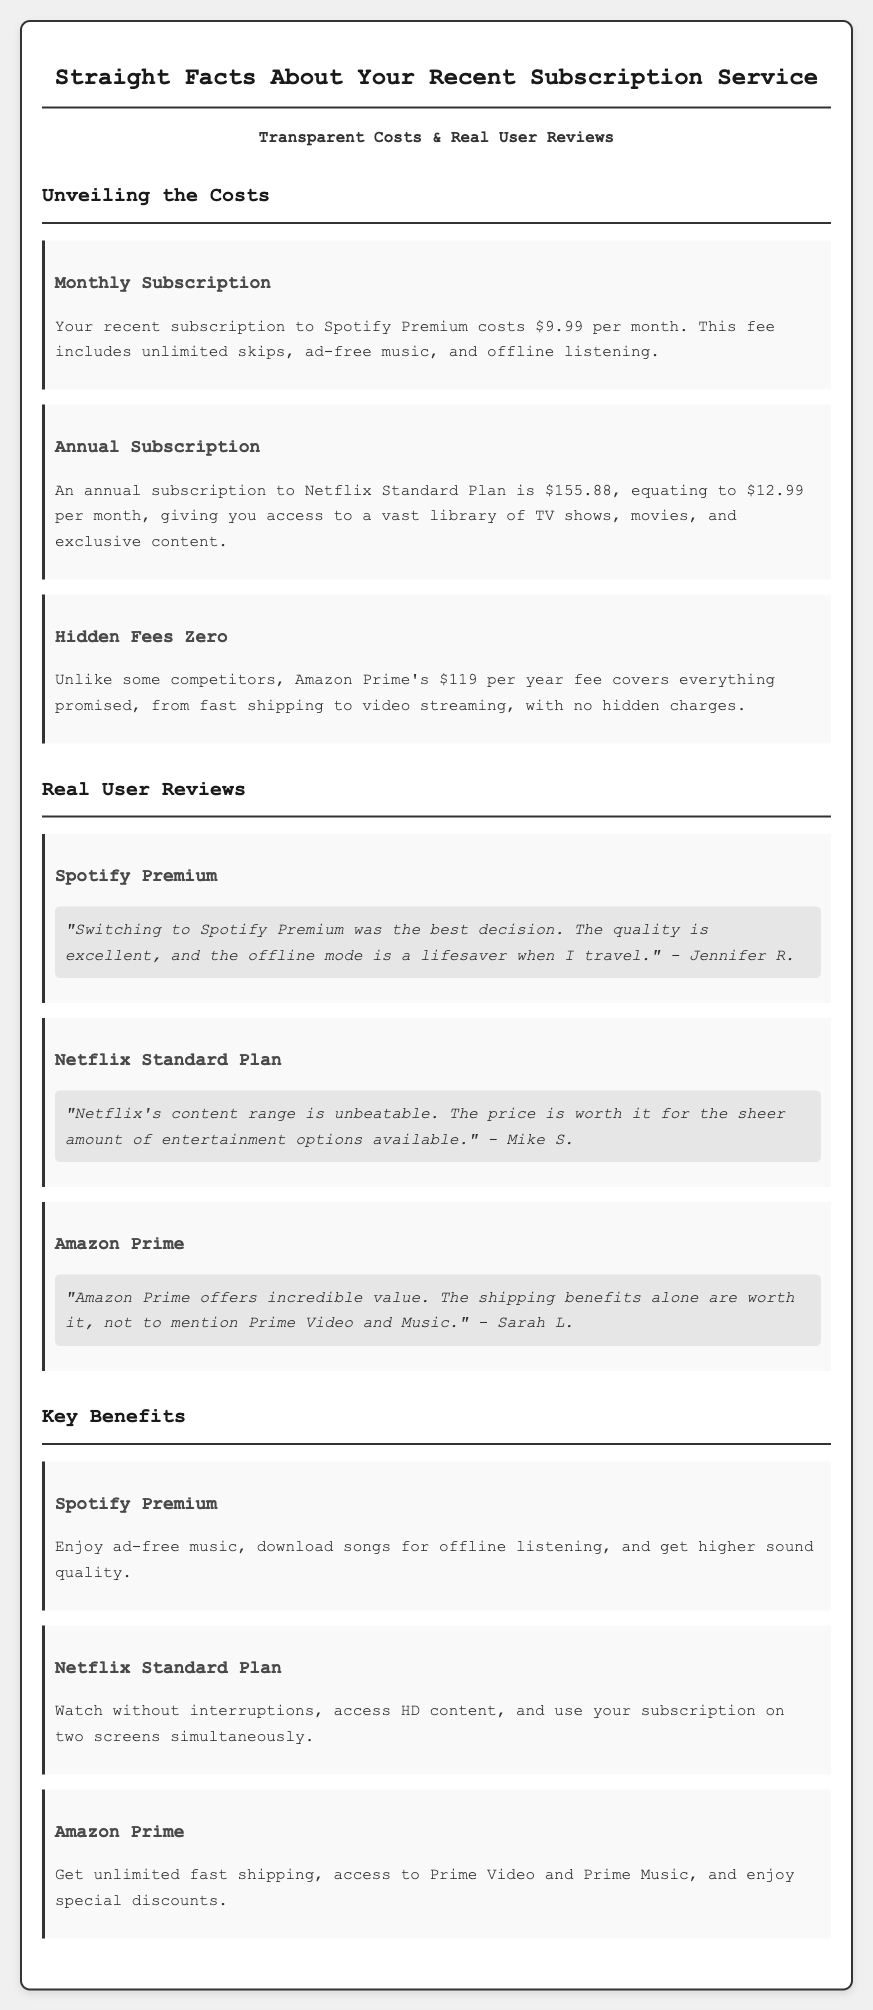What is the cost of Spotify Premium? The document states that the monthly subscription to Spotify Premium costs $9.99.
Answer: $9.99 How much is the annual subscription for Netflix Standard Plan? According to the document, the annual subscription to the Netflix Standard Plan is $155.88.
Answer: $155.88 What is stated about hidden fees for Amazon Prime? The document claims that Amazon Prime's fee covers everything promised with no hidden charges.
Answer: No hidden charges Who left a review for Spotify Premium? The document includes a review from Jennifer R. regarding Spotify Premium.
Answer: Jennifer R What key benefit of Netflix Standard Plan is mentioned? The document mentions that you can watch without interruptions as a benefit of Netflix Standard Plan.
Answer: Watch without interruptions What do users get with the Amazon Prime subscription? The document states that you get unlimited fast shipping and access to Prime Video and Prime Music.
Answer: Unlimited fast shipping, Prime Video, Prime Music What kind of content can you access with Netflix? The document explains that you have access to a vast library of TV shows and movies.
Answer: TV shows, movies How many screens can you use Netflix Standard Plan on? The document specifies that you can use your subscription on two screens simultaneously.
Answer: Two screens 